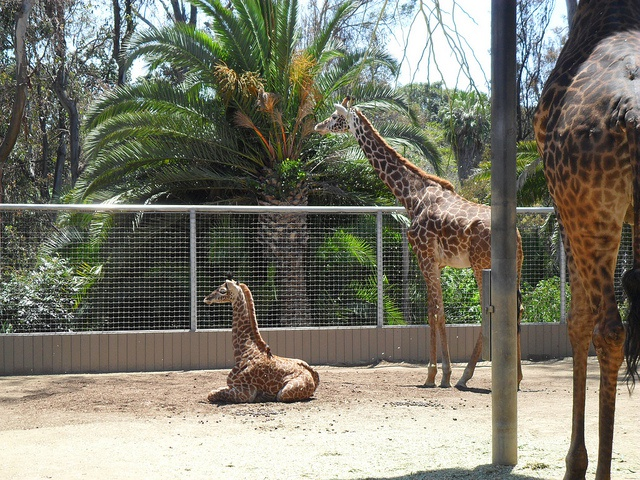Describe the objects in this image and their specific colors. I can see giraffe in gray, black, and maroon tones, giraffe in gray, maroon, and black tones, and giraffe in gray, maroon, and black tones in this image. 